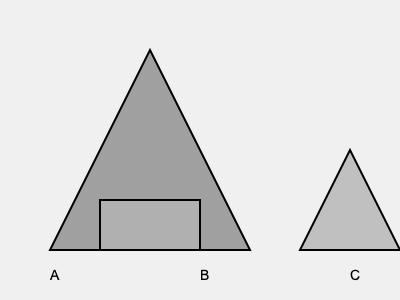Which of the 3D-printed prototype designs (A, B, or C) is likely to be the most structurally sound for presentation to potential investors? To determine the most structurally sound 3D-printed prototype design, we need to consider several factors:

1. Geometry: 
   - Design A is a triangle, which is known for its structural stability.
   - Design B is a rectangle, which can be stable but may be prone to tipping.
   - Design C is a small triangle, which is stable but has a smaller base.

2. Base width:
   - Design A has the widest base, spanning from 50 to 250 on the x-axis.
   - Design B has a moderate base width of 100 units.
   - Design C has the narrowest base, spanning only 100 units.

3. Height-to-base ratio:
   - Design A has a favorable height-to-base ratio, with its height being about 2/3 of its base width.
   - Design B has a height-to-base ratio of 1:2, which is less stable than A.
   - Design C has a height-to-base ratio of 1:1, which is less stable than A.

4. Center of gravity:
   - Design A's center of gravity is low and centered, increasing stability.
   - Design B's center of gravity is higher, potentially reducing stability.
   - Design C's center of gravity is relatively high for its small base.

5. Load distribution:
   - Design A's triangular shape allows for even load distribution from top to base.
   - Design B's rectangular shape may concentrate stress at the corners.
   - Design C's small triangular shape may not distribute loads as effectively as A.

Considering these factors, Design A (the large triangle) is likely to be the most structurally sound. Its wide base, favorable height-to-base ratio, low center of gravity, and even load distribution make it the most stable and resistant to external forces.
Answer: A (large triangle) 